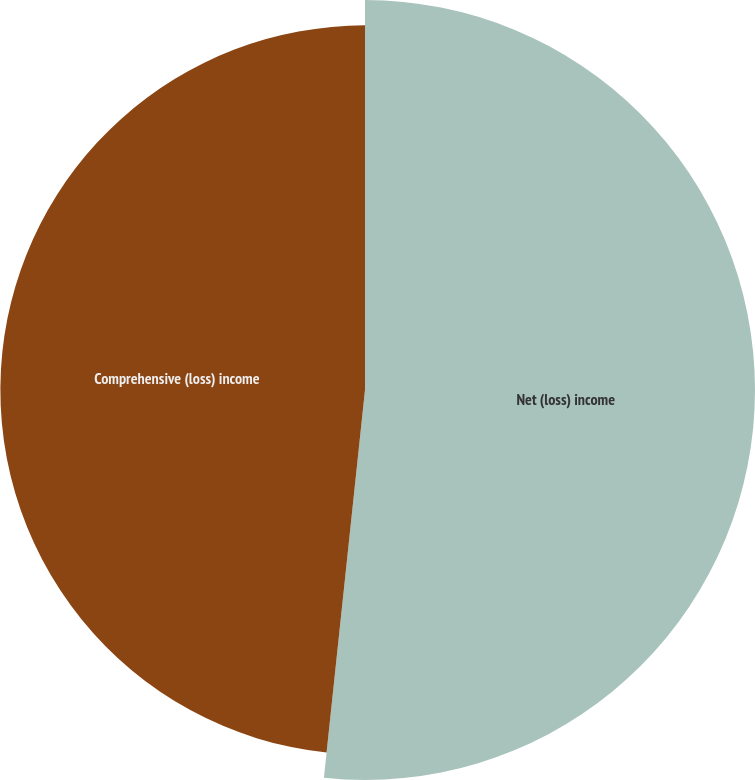<chart> <loc_0><loc_0><loc_500><loc_500><pie_chart><fcel>Net (loss) income<fcel>Comprehensive (loss) income<nl><fcel>51.68%<fcel>48.32%<nl></chart> 